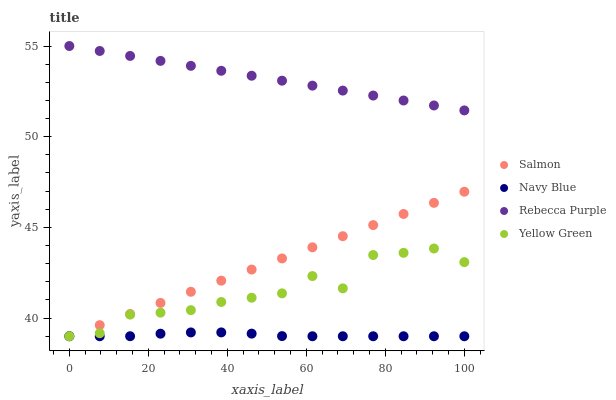Does Navy Blue have the minimum area under the curve?
Answer yes or no. Yes. Does Rebecca Purple have the maximum area under the curve?
Answer yes or no. Yes. Does Salmon have the minimum area under the curve?
Answer yes or no. No. Does Salmon have the maximum area under the curve?
Answer yes or no. No. Is Salmon the smoothest?
Answer yes or no. Yes. Is Yellow Green the roughest?
Answer yes or no. Yes. Is Rebecca Purple the smoothest?
Answer yes or no. No. Is Rebecca Purple the roughest?
Answer yes or no. No. Does Navy Blue have the lowest value?
Answer yes or no. Yes. Does Rebecca Purple have the lowest value?
Answer yes or no. No. Does Rebecca Purple have the highest value?
Answer yes or no. Yes. Does Salmon have the highest value?
Answer yes or no. No. Is Navy Blue less than Rebecca Purple?
Answer yes or no. Yes. Is Rebecca Purple greater than Salmon?
Answer yes or no. Yes. Does Navy Blue intersect Yellow Green?
Answer yes or no. Yes. Is Navy Blue less than Yellow Green?
Answer yes or no. No. Is Navy Blue greater than Yellow Green?
Answer yes or no. No. Does Navy Blue intersect Rebecca Purple?
Answer yes or no. No. 